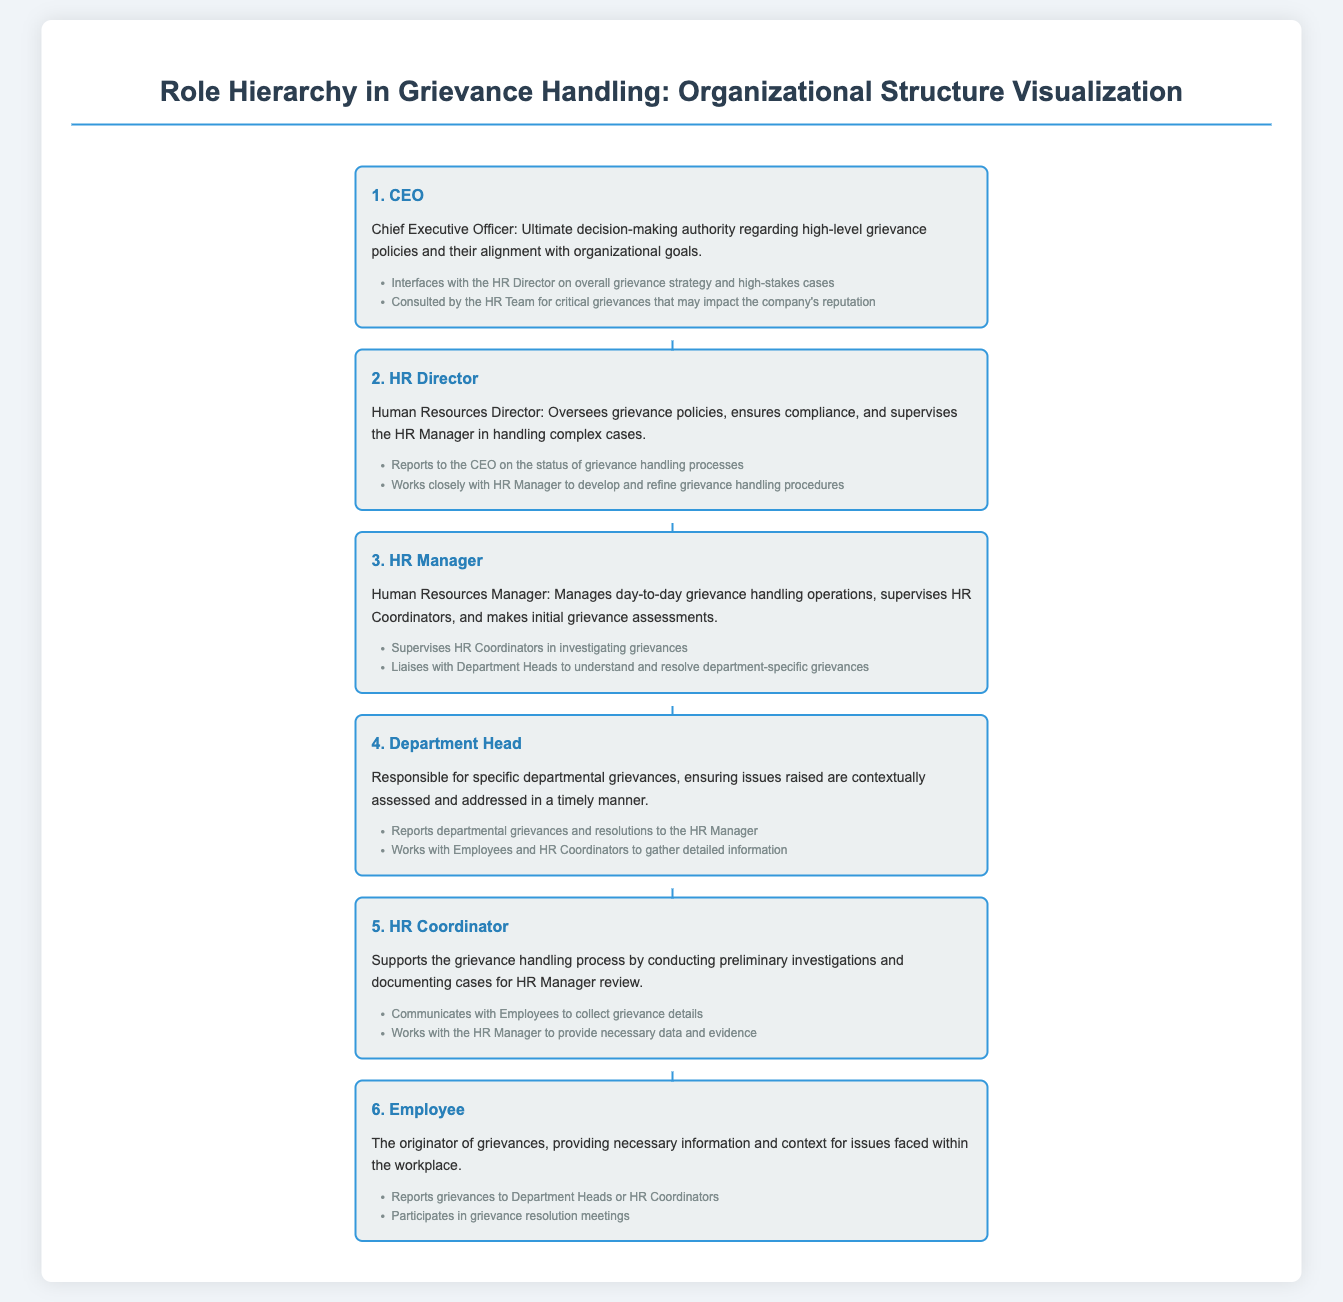What is the highest role in grievance handling? The highest role in grievance handling is identified as the Chief Executive Officer.
Answer: CEO Who supervises the HR Coordinators? The HR Manager is responsible for supervising the HR Coordinators in grievance investigations.
Answer: HR Manager What is the primary responsibility of the HR Director? The HR Director oversees grievance policies and compliance within the organization.
Answer: Oversees grievance policies How does the HR Coordinator support the grievance process? The HR Coordinator conducts preliminary investigations and documents cases for review by the HR Manager.
Answer: Conducts preliminary investigations Which role reports grievances to the HR Manager? The Department Head is responsible for reporting departmental grievances to the HR Manager.
Answer: Department Head What is the role of the Employee in the grievance process? The Employee is the originator of grievances and provides information regarding workplace issues.
Answer: Originator of grievances Who works closely with the HR Manager to develop grievance handling procedures? The HR Director collaborates with the HR Manager on developing grievance handling procedures.
Answer: HR Director What does the Employee participate in during the grievance handling process? The Employee participates in grievance resolution meetings to discuss and resolve their issues.
Answer: Grievance resolution meetings 